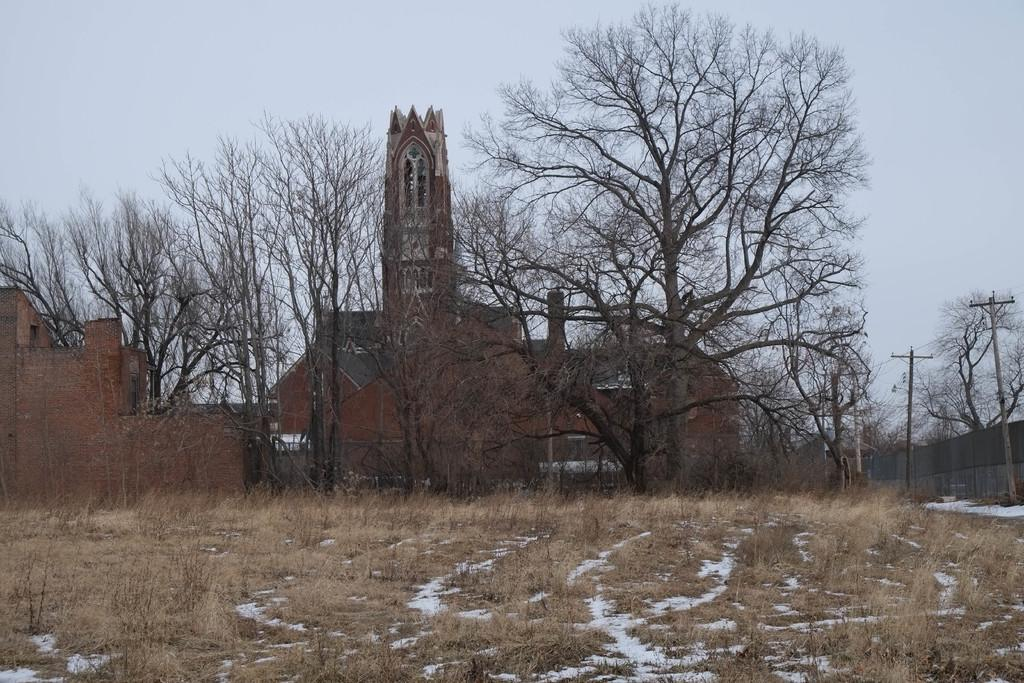What type of vegetation is present on the ground in the image? There are plants on the ground in the image. What can be seen in the background of the image? There are buildings, trees, electric poles, and the sky visible in the background. What type of spark can be seen coming from the cable in the image? There is no cable present in the image, so it is not possible to determine if there is any spark. How many beginner plants can be seen in the image? There is no indication in the image that any of the plants are beginners, so it cannot be determined from the picture. 